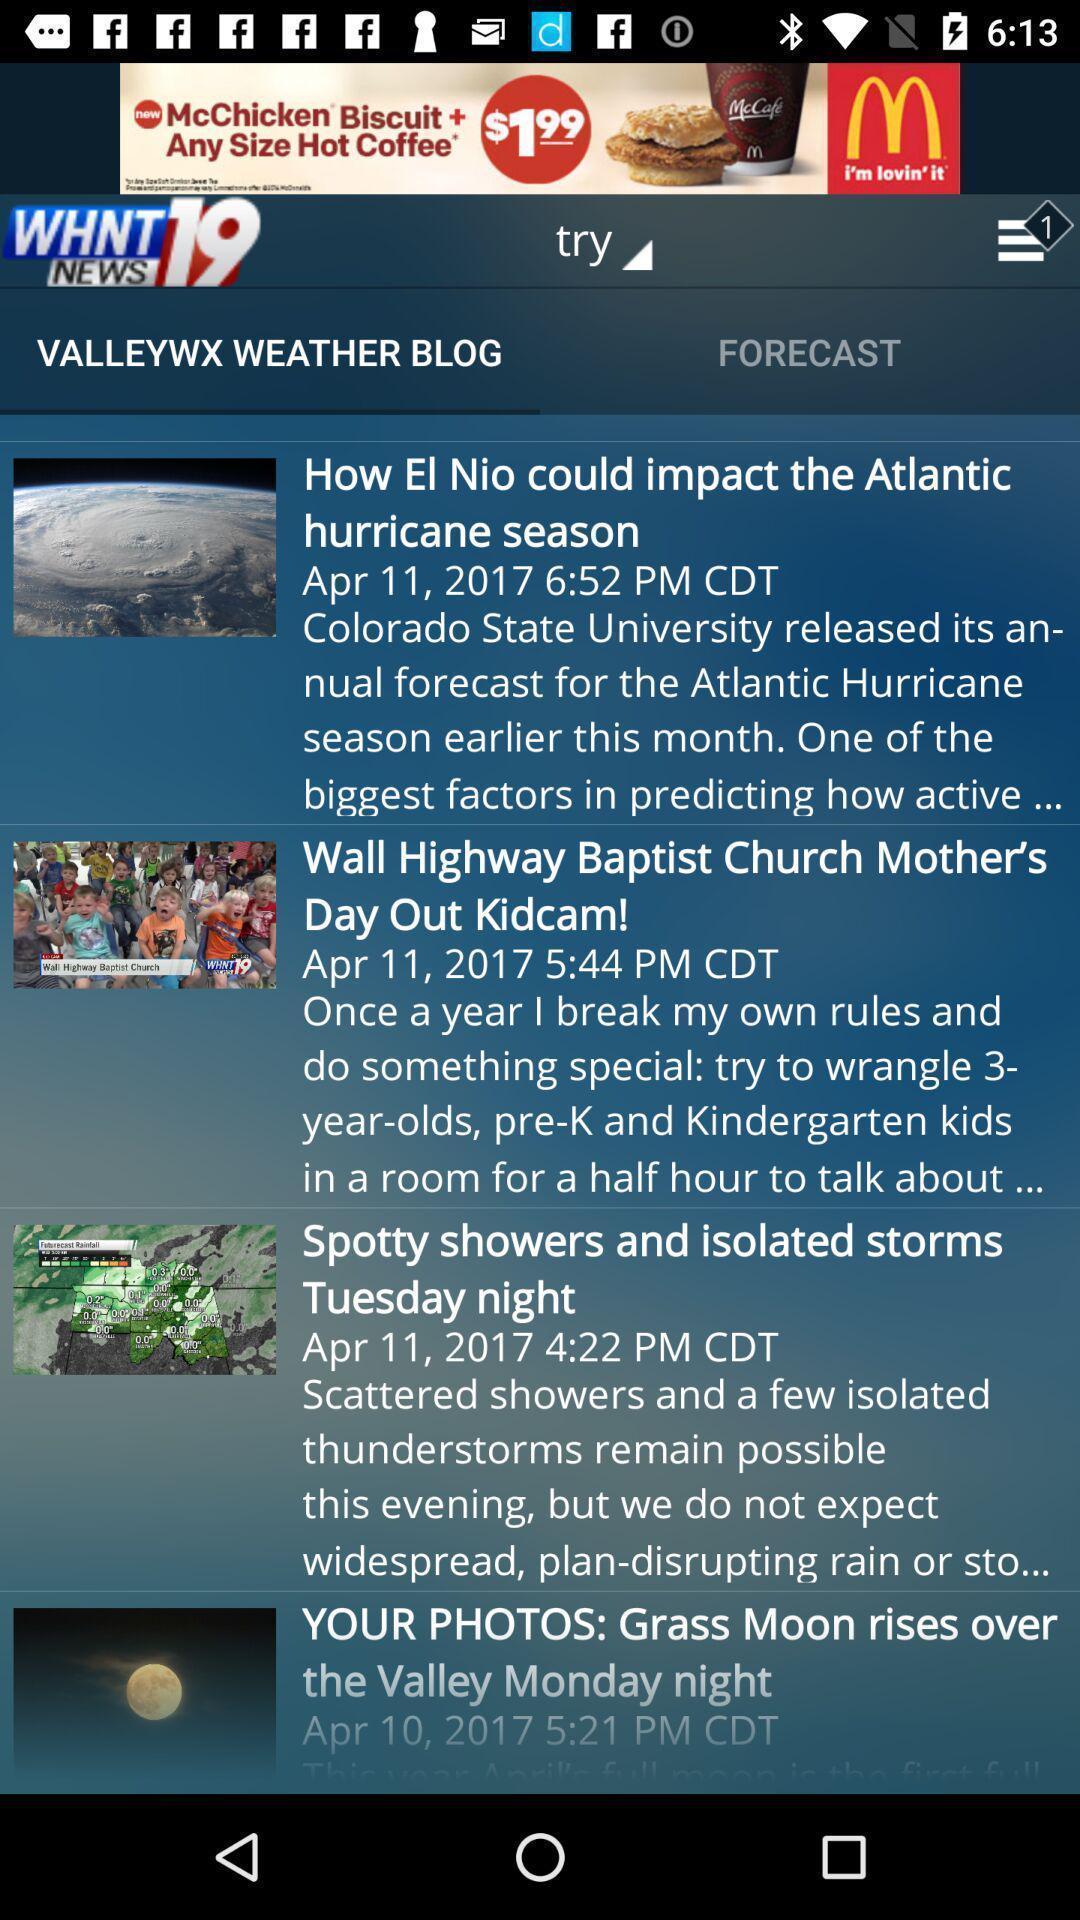Summarize the information in this screenshot. Screen displaying list of news. 